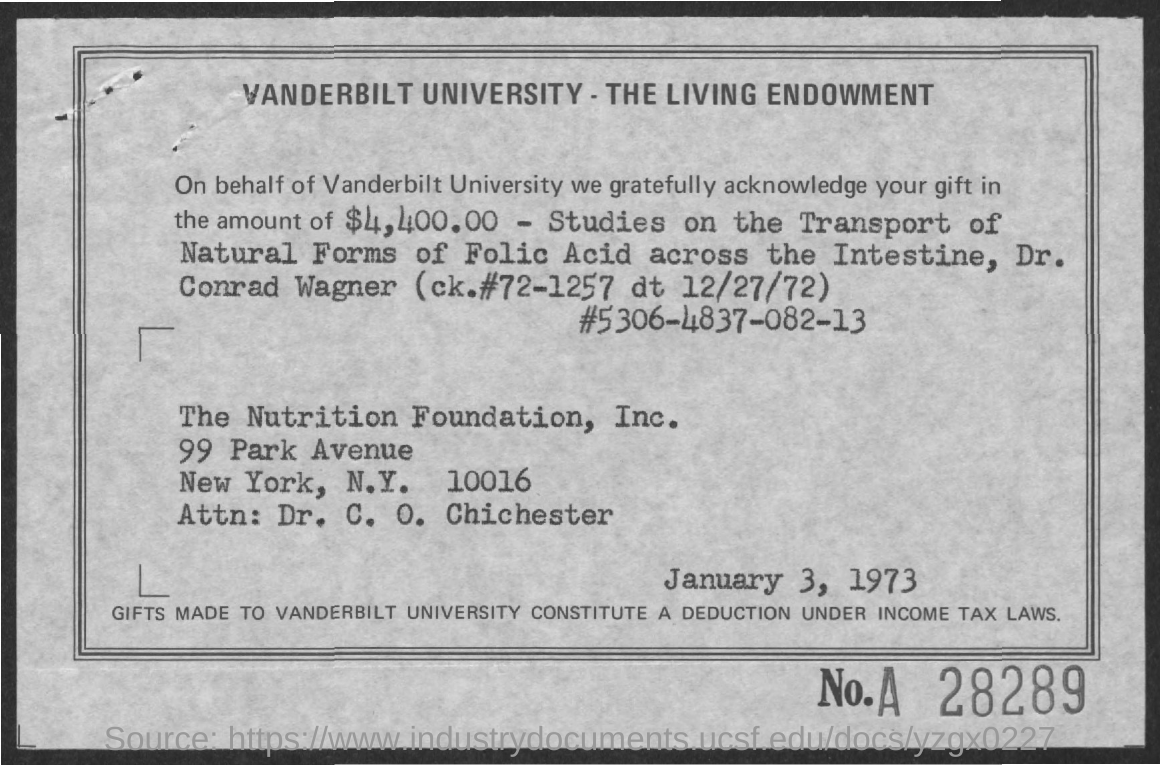Mention a couple of crucial points in this snapshot. I gifted the amount with the purpose of studying the transport of natural forms of folic acid across the intestine for the purpose of scientific research. The value of the gifted amount mentioned on the given page is $4,400.00. 